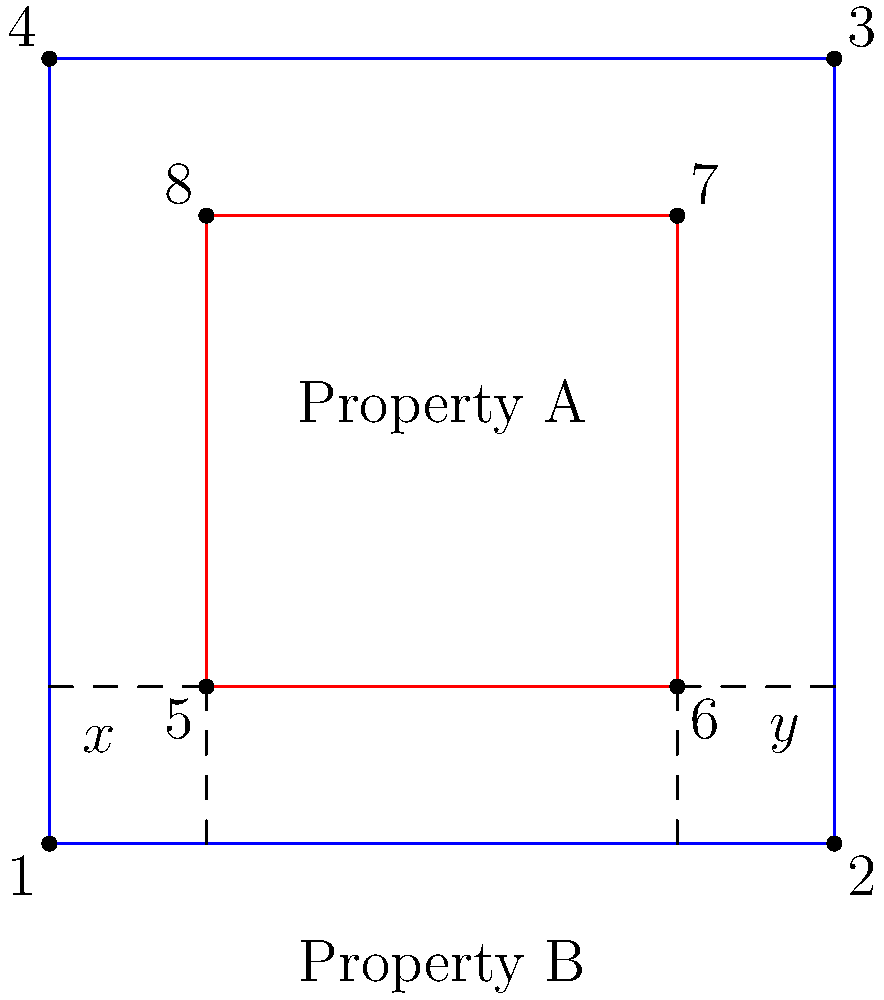In the survey map shown, Property A (blue outline) and Property B (red outline) have overlapping boundaries. The discrepancy is represented by the areas marked $x$ and $y$. If the total area of discrepancy is 800 square feet, and the ratio of $x$ to $y$ is 1:3, what is the area of discrepancy $x$ in square feet? To solve this problem, let's follow these steps:

1. Understand the given information:
   - Total area of discrepancy = 800 square feet
   - Ratio of $x$ to $y$ is 1:3

2. Set up an equation to represent the total area:
   $x + y = 800$

3. Express $y$ in terms of $x$ using the given ratio:
   $y = 3x$

4. Substitute this expression into the total area equation:
   $x + 3x = 800$
   $4x = 800$

5. Solve for $x$:
   $x = 800 \div 4 = 200$

Therefore, the area of discrepancy $x$ is 200 square feet.
Answer: 200 square feet 